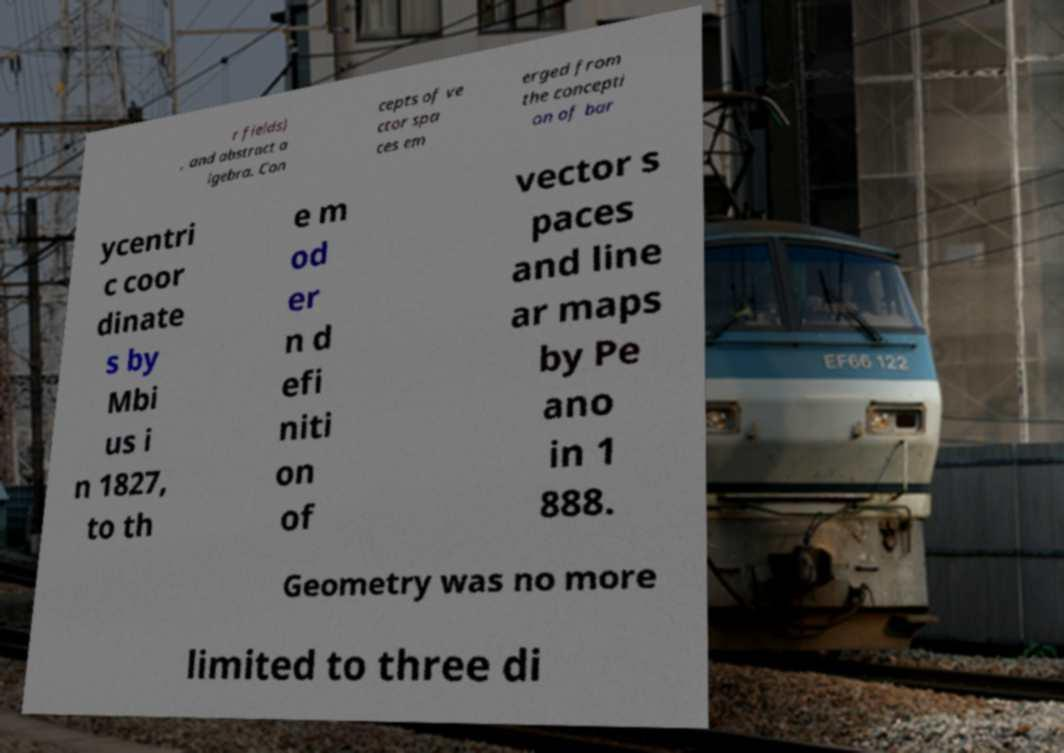There's text embedded in this image that I need extracted. Can you transcribe it verbatim? r fields) , and abstract a lgebra. Con cepts of ve ctor spa ces em erged from the concepti on of bar ycentri c coor dinate s by Mbi us i n 1827, to th e m od er n d efi niti on of vector s paces and line ar maps by Pe ano in 1 888. Geometry was no more limited to three di 